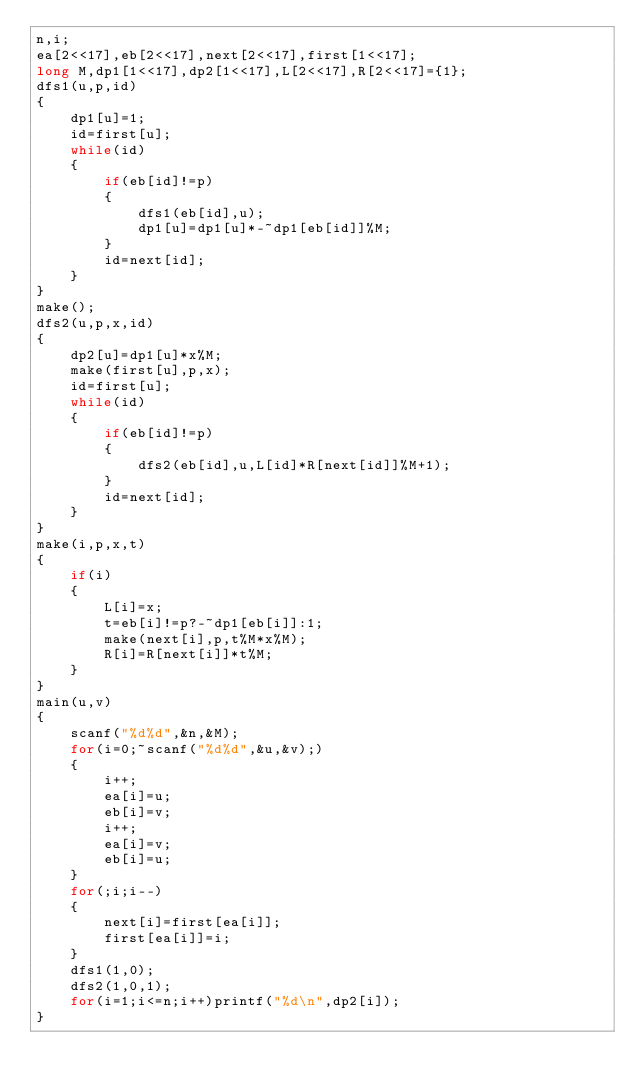<code> <loc_0><loc_0><loc_500><loc_500><_C_>n,i;
ea[2<<17],eb[2<<17],next[2<<17],first[1<<17];
long M,dp1[1<<17],dp2[1<<17],L[2<<17],R[2<<17]={1};
dfs1(u,p,id)
{
	dp1[u]=1;
	id=first[u];
	while(id)
	{
		if(eb[id]!=p)
		{
			dfs1(eb[id],u);
			dp1[u]=dp1[u]*-~dp1[eb[id]]%M;
		}
		id=next[id];
	}
}
make();
dfs2(u,p,x,id)
{
	dp2[u]=dp1[u]*x%M;
	make(first[u],p,x);
	id=first[u];
	while(id)
	{
		if(eb[id]!=p)
		{
			dfs2(eb[id],u,L[id]*R[next[id]]%M+1);
		}
		id=next[id];
	}
}
make(i,p,x,t)
{
	if(i)
	{
		L[i]=x;
		t=eb[i]!=p?-~dp1[eb[i]]:1;
		make(next[i],p,t%M*x%M);
		R[i]=R[next[i]]*t%M;
	}
}
main(u,v)
{
	scanf("%d%d",&n,&M);
	for(i=0;~scanf("%d%d",&u,&v);)
	{
		i++;
		ea[i]=u;
		eb[i]=v;
		i++;
		ea[i]=v;
		eb[i]=u;
	}
	for(;i;i--)
	{
		next[i]=first[ea[i]];
		first[ea[i]]=i;
	}
	dfs1(1,0);
	dfs2(1,0,1);
	for(i=1;i<=n;i++)printf("%d\n",dp2[i]);
}</code> 